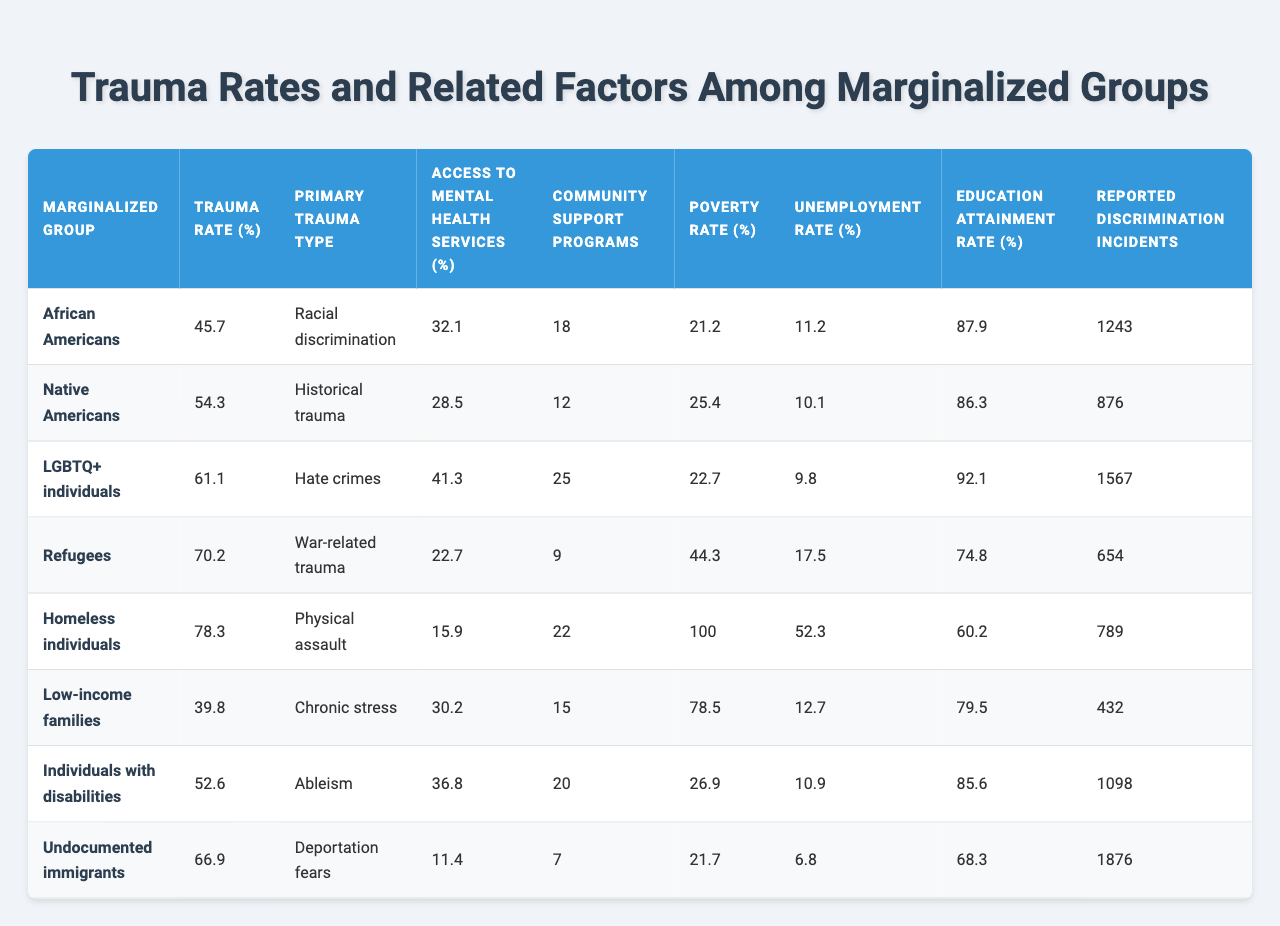What is the trauma rate for Native Americans? The trauma rate for Native Americans is listed in the table under the "Trauma Rate (%)" column corresponding to their entry. That value is 54.3.
Answer: 54.3% Which marginalized group has the highest reported discrimination incidents? The "Reported Discrimination Incidents" column shows the counts for each group. Undocumented immigrants have the highest count at 1876.
Answer: 1876 What is the average access to mental health services among the listed groups? To find the average, sum the access percentages (32.1 + 28.5 + 41.3 + 22.7 + 15.9 + 30.2 + 36.8 + 11.4) =  218.0, then divide by 8 (the number of groups) to get 27.25.
Answer: 27.25% Is the unemployment rate for homeless individuals higher than for low-income families? The unemployment rates for homeless individuals and low-income families are 52.3 and 12.7, respectively. Since 52.3 is greater than 12.7, the statement is true.
Answer: Yes How do the poverty rates compare between Refugees and Low-income families? The poverty rate for Refugees is 44.3%, while for Low-income families it is 78.5%. Low-income families have a higher poverty rate than Refugees by subtracting these values (78.5 - 44.3 = 34.2).
Answer: Low-income families have a higher poverty rate by 34.2% Which group has the least access to mental health services, and what is that percentage? By checking the "Access to Mental Health Services (%)" column, the lowest percentage is for homeless individuals at 15.9%.
Answer: 15.9% What is the difference in trauma rates between LGBTQ+ individuals and African Americans? The trauma rate for LGBTQ+ individuals is 61.1%, and for African Americans, it is 45.7%. Finding the difference gives us (61.1 - 45.7) = 15.4.
Answer: 15.4% Is it true that both Native Americans and Undocumented immigrants have above 60% trauma rates? The trauma rate for Native Americans is 54.3%, and for Undocumented immigrants, it is 66.9%. Since Native Americans have a trauma rate below 60%, the statement is false.
Answer: No Calculate the total number of reported discrimination incidents across all groups. Adding the values from the "Reported Discrimination Incidents" column gives (1243 + 876 + 1567 + 654 + 789 + 432 + 1098 + 1876) =  8035.
Answer: 8035 Which group has the highest education attainment rate and what is that rate? Checking the "Education Attainment Rate (%)" column shows that LGBTQ+ individuals have the highest rate at 92.1%.
Answer: 92.1% 